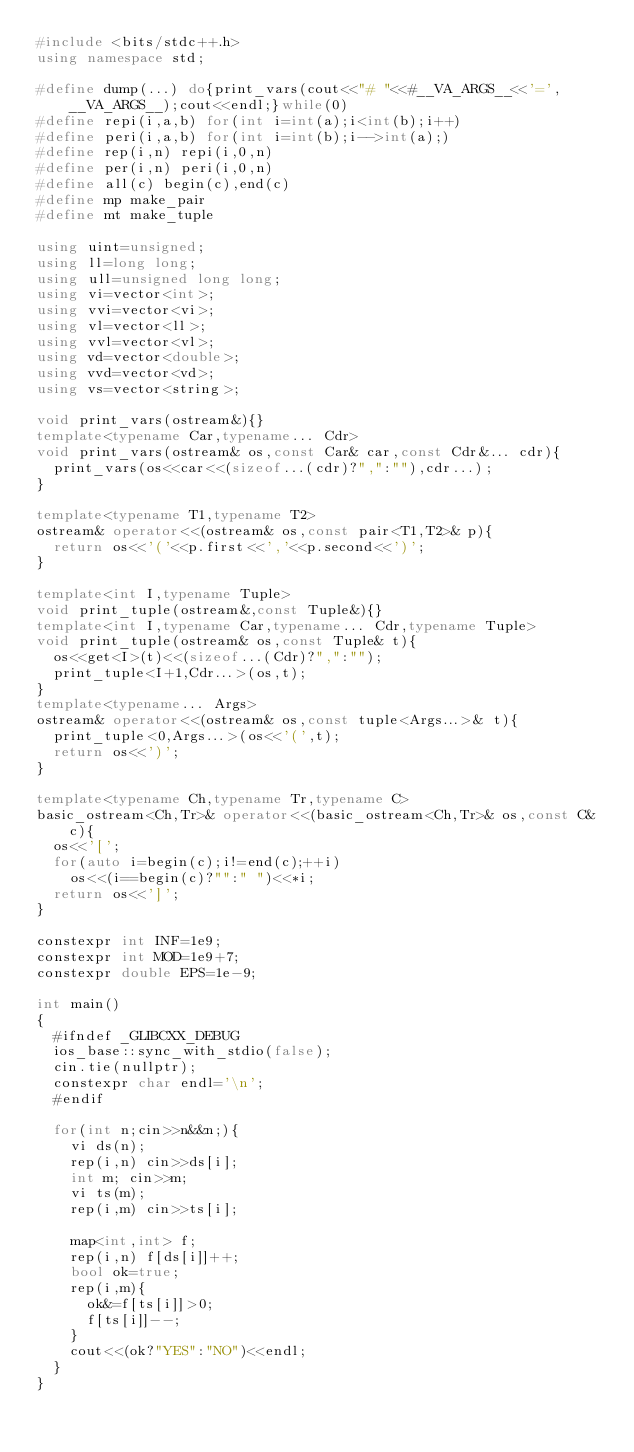<code> <loc_0><loc_0><loc_500><loc_500><_C++_>#include <bits/stdc++.h>
using namespace std;

#define dump(...) do{print_vars(cout<<"# "<<#__VA_ARGS__<<'=',__VA_ARGS__);cout<<endl;}while(0)
#define repi(i,a,b) for(int i=int(a);i<int(b);i++)
#define peri(i,a,b) for(int i=int(b);i-->int(a);)
#define rep(i,n) repi(i,0,n)
#define per(i,n) peri(i,0,n)
#define all(c) begin(c),end(c)
#define mp make_pair
#define mt make_tuple

using uint=unsigned;
using ll=long long;
using ull=unsigned long long;
using vi=vector<int>;
using vvi=vector<vi>;
using vl=vector<ll>;
using vvl=vector<vl>;
using vd=vector<double>;
using vvd=vector<vd>;
using vs=vector<string>;

void print_vars(ostream&){}
template<typename Car,typename... Cdr>
void print_vars(ostream& os,const Car& car,const Cdr&... cdr){
	print_vars(os<<car<<(sizeof...(cdr)?",":""),cdr...);
}

template<typename T1,typename T2>
ostream& operator<<(ostream& os,const pair<T1,T2>& p){
	return os<<'('<<p.first<<','<<p.second<<')';
}

template<int I,typename Tuple>
void print_tuple(ostream&,const Tuple&){}
template<int I,typename Car,typename... Cdr,typename Tuple>
void print_tuple(ostream& os,const Tuple& t){
	os<<get<I>(t)<<(sizeof...(Cdr)?",":"");
	print_tuple<I+1,Cdr...>(os,t);
}
template<typename... Args>
ostream& operator<<(ostream& os,const tuple<Args...>& t){
	print_tuple<0,Args...>(os<<'(',t);
	return os<<')';
}

template<typename Ch,typename Tr,typename C>
basic_ostream<Ch,Tr>& operator<<(basic_ostream<Ch,Tr>& os,const C& c){
	os<<'[';
	for(auto i=begin(c);i!=end(c);++i)
		os<<(i==begin(c)?"":" ")<<*i;
	return os<<']';
}

constexpr int INF=1e9;
constexpr int MOD=1e9+7;
constexpr double EPS=1e-9;

int main()
{
	#ifndef _GLIBCXX_DEBUG
	ios_base::sync_with_stdio(false);
	cin.tie(nullptr);
	constexpr char endl='\n';
	#endif

	for(int n;cin>>n&&n;){
		vi ds(n);
		rep(i,n) cin>>ds[i];
		int m; cin>>m;
		vi ts(m);
		rep(i,m) cin>>ts[i];

		map<int,int> f;
		rep(i,n) f[ds[i]]++;
		bool ok=true;
		rep(i,m){
			ok&=f[ts[i]]>0;
			f[ts[i]]--;
		}
		cout<<(ok?"YES":"NO")<<endl;
	}
}
</code> 